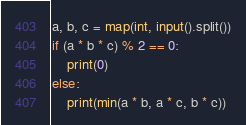<code> <loc_0><loc_0><loc_500><loc_500><_Python_>a, b, c = map(int, input().split())
if (a * b * c) % 2 == 0:
    print(0)
else:
    print(min(a * b, a * c, b * c))</code> 